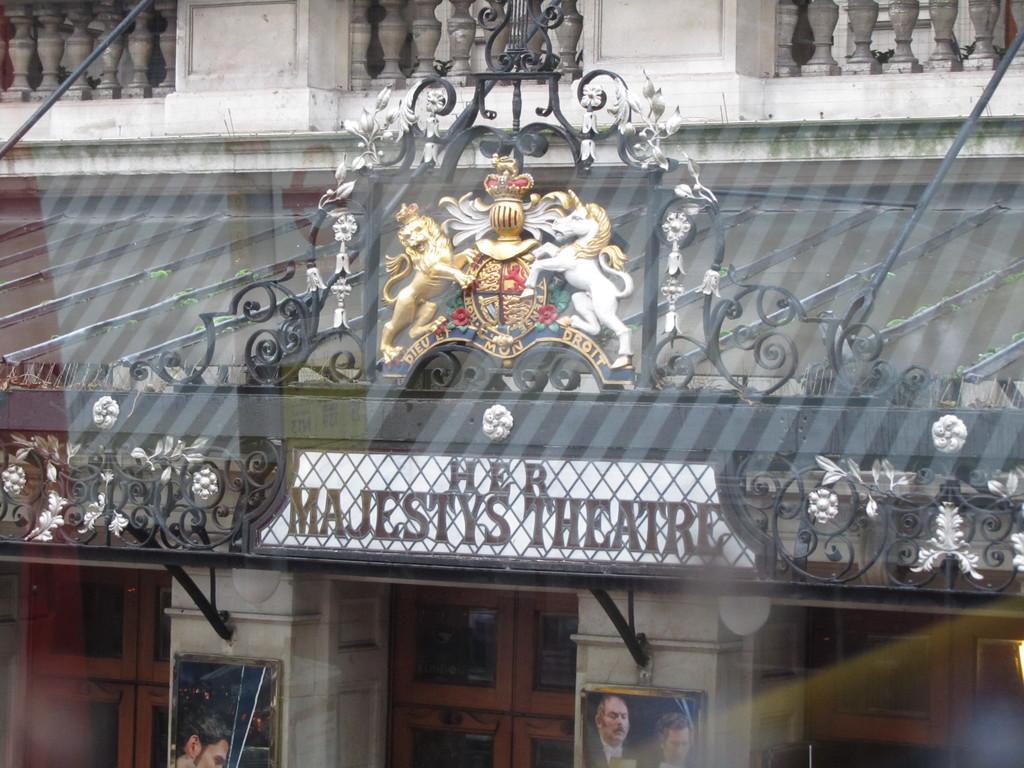Please provide a concise description of this image. In this image there is building. There is a board with text. There are photos on the pillars. There is a balcony at the top I think. 